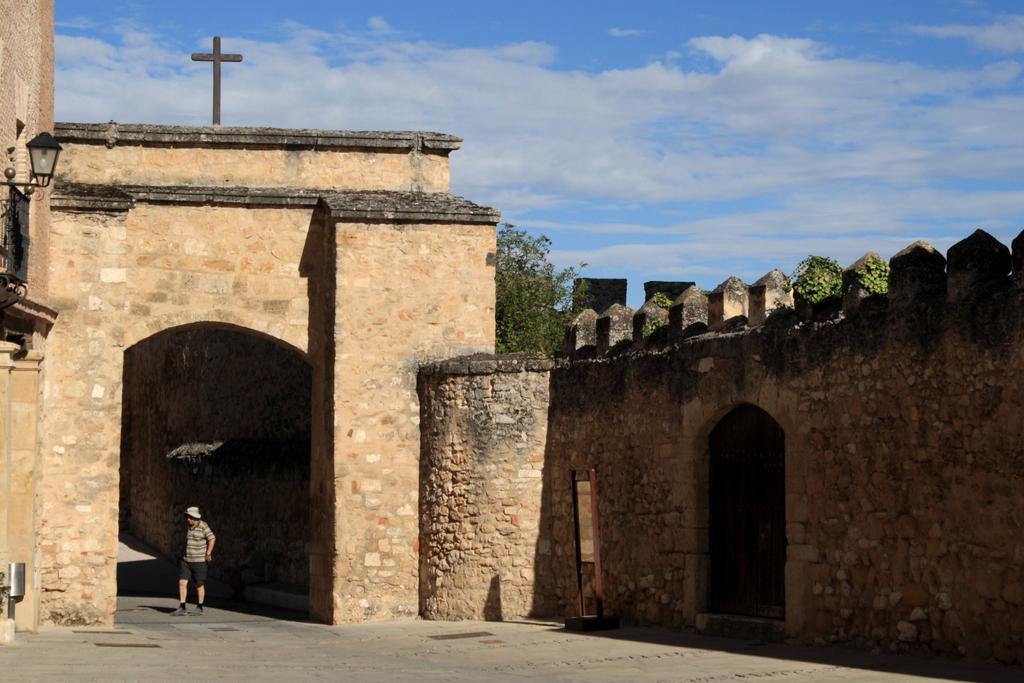What is the main structure in the picture? There is a fort in the picture. What religious symbol is present above the fort? There is a Christ cross above the fort. Can you describe the location of the man in the image? There is a man under the roof of the fort. What type of grain is being harvested in the yard of the fort? There is no yard or grain present in the image; it only features a fort with a Christ cross above it and a man under the roof. 